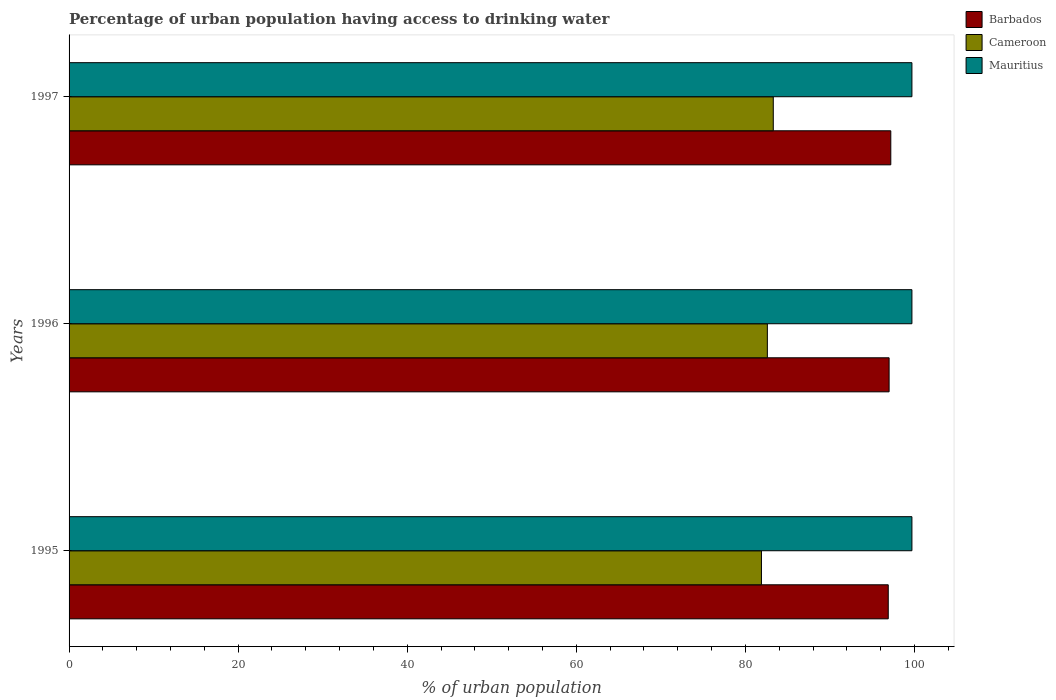How many different coloured bars are there?
Ensure brevity in your answer.  3. Are the number of bars per tick equal to the number of legend labels?
Make the answer very short. Yes. What is the percentage of urban population having access to drinking water in Cameroon in 1996?
Offer a very short reply. 82.6. Across all years, what is the maximum percentage of urban population having access to drinking water in Mauritius?
Your answer should be compact. 99.7. Across all years, what is the minimum percentage of urban population having access to drinking water in Cameroon?
Provide a short and direct response. 81.9. What is the total percentage of urban population having access to drinking water in Barbados in the graph?
Provide a short and direct response. 291.1. What is the difference between the percentage of urban population having access to drinking water in Cameroon in 1995 and that in 1997?
Provide a succinct answer. -1.4. What is the difference between the percentage of urban population having access to drinking water in Barbados in 1997 and the percentage of urban population having access to drinking water in Cameroon in 1995?
Your answer should be very brief. 15.3. What is the average percentage of urban population having access to drinking water in Barbados per year?
Give a very brief answer. 97.03. In the year 1996, what is the difference between the percentage of urban population having access to drinking water in Barbados and percentage of urban population having access to drinking water in Mauritius?
Your response must be concise. -2.7. In how many years, is the percentage of urban population having access to drinking water in Barbados greater than 88 %?
Keep it short and to the point. 3. What is the ratio of the percentage of urban population having access to drinking water in Cameroon in 1995 to that in 1997?
Provide a succinct answer. 0.98. What is the difference between the highest and the second highest percentage of urban population having access to drinking water in Barbados?
Your response must be concise. 0.2. What is the difference between the highest and the lowest percentage of urban population having access to drinking water in Cameroon?
Your answer should be very brief. 1.4. What does the 1st bar from the top in 1995 represents?
Your answer should be compact. Mauritius. What does the 1st bar from the bottom in 1997 represents?
Your answer should be compact. Barbados. Is it the case that in every year, the sum of the percentage of urban population having access to drinking water in Barbados and percentage of urban population having access to drinking water in Cameroon is greater than the percentage of urban population having access to drinking water in Mauritius?
Keep it short and to the point. Yes. Are the values on the major ticks of X-axis written in scientific E-notation?
Your response must be concise. No. What is the title of the graph?
Your answer should be compact. Percentage of urban population having access to drinking water. Does "Congo (Democratic)" appear as one of the legend labels in the graph?
Keep it short and to the point. No. What is the label or title of the X-axis?
Offer a terse response. % of urban population. What is the label or title of the Y-axis?
Offer a very short reply. Years. What is the % of urban population of Barbados in 1995?
Ensure brevity in your answer.  96.9. What is the % of urban population of Cameroon in 1995?
Offer a very short reply. 81.9. What is the % of urban population of Mauritius in 1995?
Give a very brief answer. 99.7. What is the % of urban population of Barbados in 1996?
Your answer should be very brief. 97. What is the % of urban population of Cameroon in 1996?
Your answer should be compact. 82.6. What is the % of urban population of Mauritius in 1996?
Offer a terse response. 99.7. What is the % of urban population of Barbados in 1997?
Your response must be concise. 97.2. What is the % of urban population of Cameroon in 1997?
Provide a succinct answer. 83.3. What is the % of urban population in Mauritius in 1997?
Make the answer very short. 99.7. Across all years, what is the maximum % of urban population of Barbados?
Keep it short and to the point. 97.2. Across all years, what is the maximum % of urban population of Cameroon?
Your answer should be very brief. 83.3. Across all years, what is the maximum % of urban population in Mauritius?
Offer a very short reply. 99.7. Across all years, what is the minimum % of urban population in Barbados?
Offer a terse response. 96.9. Across all years, what is the minimum % of urban population of Cameroon?
Provide a short and direct response. 81.9. Across all years, what is the minimum % of urban population of Mauritius?
Keep it short and to the point. 99.7. What is the total % of urban population of Barbados in the graph?
Give a very brief answer. 291.1. What is the total % of urban population of Cameroon in the graph?
Give a very brief answer. 247.8. What is the total % of urban population in Mauritius in the graph?
Your answer should be very brief. 299.1. What is the difference between the % of urban population in Cameroon in 1995 and that in 1996?
Provide a succinct answer. -0.7. What is the difference between the % of urban population of Mauritius in 1995 and that in 1996?
Provide a succinct answer. 0. What is the difference between the % of urban population of Barbados in 1995 and that in 1997?
Ensure brevity in your answer.  -0.3. What is the difference between the % of urban population of Cameroon in 1995 and that in 1997?
Give a very brief answer. -1.4. What is the difference between the % of urban population in Cameroon in 1996 and that in 1997?
Ensure brevity in your answer.  -0.7. What is the difference between the % of urban population in Barbados in 1995 and the % of urban population in Cameroon in 1996?
Your answer should be compact. 14.3. What is the difference between the % of urban population of Cameroon in 1995 and the % of urban population of Mauritius in 1996?
Offer a very short reply. -17.8. What is the difference between the % of urban population of Barbados in 1995 and the % of urban population of Cameroon in 1997?
Offer a very short reply. 13.6. What is the difference between the % of urban population in Cameroon in 1995 and the % of urban population in Mauritius in 1997?
Your response must be concise. -17.8. What is the difference between the % of urban population of Barbados in 1996 and the % of urban population of Cameroon in 1997?
Your answer should be compact. 13.7. What is the difference between the % of urban population in Cameroon in 1996 and the % of urban population in Mauritius in 1997?
Your answer should be very brief. -17.1. What is the average % of urban population of Barbados per year?
Give a very brief answer. 97.03. What is the average % of urban population in Cameroon per year?
Your response must be concise. 82.6. What is the average % of urban population in Mauritius per year?
Your response must be concise. 99.7. In the year 1995, what is the difference between the % of urban population in Cameroon and % of urban population in Mauritius?
Provide a short and direct response. -17.8. In the year 1996, what is the difference between the % of urban population in Barbados and % of urban population in Mauritius?
Your response must be concise. -2.7. In the year 1996, what is the difference between the % of urban population of Cameroon and % of urban population of Mauritius?
Your answer should be compact. -17.1. In the year 1997, what is the difference between the % of urban population of Barbados and % of urban population of Cameroon?
Your response must be concise. 13.9. In the year 1997, what is the difference between the % of urban population in Barbados and % of urban population in Mauritius?
Your answer should be compact. -2.5. In the year 1997, what is the difference between the % of urban population of Cameroon and % of urban population of Mauritius?
Keep it short and to the point. -16.4. What is the ratio of the % of urban population in Barbados in 1995 to that in 1996?
Keep it short and to the point. 1. What is the ratio of the % of urban population in Mauritius in 1995 to that in 1996?
Your response must be concise. 1. What is the ratio of the % of urban population of Barbados in 1995 to that in 1997?
Your answer should be compact. 1. What is the ratio of the % of urban population of Cameroon in 1995 to that in 1997?
Keep it short and to the point. 0.98. What is the ratio of the % of urban population of Mauritius in 1995 to that in 1997?
Ensure brevity in your answer.  1. What is the ratio of the % of urban population of Barbados in 1996 to that in 1997?
Provide a short and direct response. 1. What is the ratio of the % of urban population of Cameroon in 1996 to that in 1997?
Ensure brevity in your answer.  0.99. What is the ratio of the % of urban population of Mauritius in 1996 to that in 1997?
Your answer should be very brief. 1. What is the difference between the highest and the second highest % of urban population of Barbados?
Provide a succinct answer. 0.2. What is the difference between the highest and the second highest % of urban population of Cameroon?
Your answer should be compact. 0.7. What is the difference between the highest and the lowest % of urban population in Barbados?
Provide a short and direct response. 0.3. 